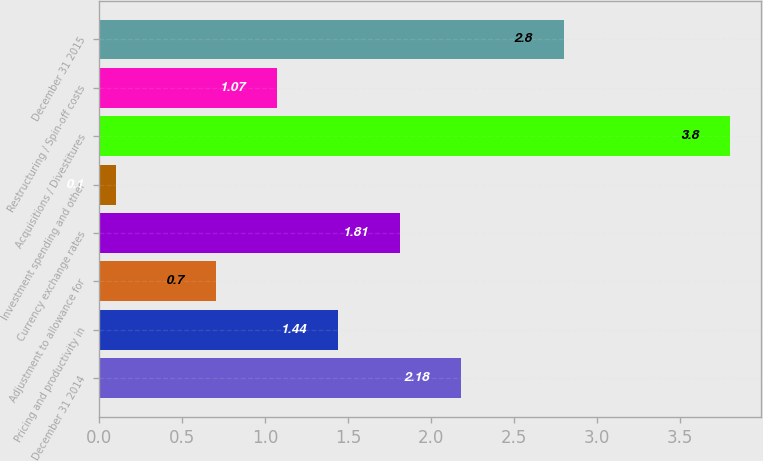<chart> <loc_0><loc_0><loc_500><loc_500><bar_chart><fcel>December 31 2014<fcel>Pricing and productivity in<fcel>Adjustment to allowance for<fcel>Currency exchange rates<fcel>Investment spending and other<fcel>Acquisitions / Divestitures<fcel>Restructuring / Spin-off costs<fcel>December 31 2015<nl><fcel>2.18<fcel>1.44<fcel>0.7<fcel>1.81<fcel>0.1<fcel>3.8<fcel>1.07<fcel>2.8<nl></chart> 